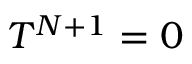Convert formula to latex. <formula><loc_0><loc_0><loc_500><loc_500>T ^ { N + 1 } = 0</formula> 